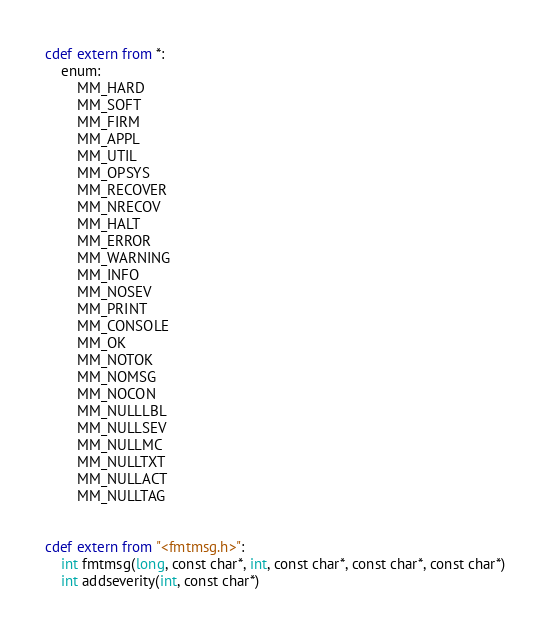Convert code to text. <code><loc_0><loc_0><loc_500><loc_500><_Cython_>

cdef extern from *:
    enum:
        MM_HARD
        MM_SOFT
        MM_FIRM
        MM_APPL
        MM_UTIL
        MM_OPSYS
        MM_RECOVER
        MM_NRECOV
        MM_HALT
        MM_ERROR
        MM_WARNING
        MM_INFO
        MM_NOSEV
        MM_PRINT
        MM_CONSOLE
        MM_OK
        MM_NOTOK
        MM_NOMSG
        MM_NOCON
        MM_NULLLBL
        MM_NULLSEV
        MM_NULLMC
        MM_NULLTXT
        MM_NULLACT
        MM_NULLTAG


cdef extern from "<fmtmsg.h>":
    int fmtmsg(long, const char*, int, const char*, const char*, const char*)
    int addseverity(int, const char*)


</code> 